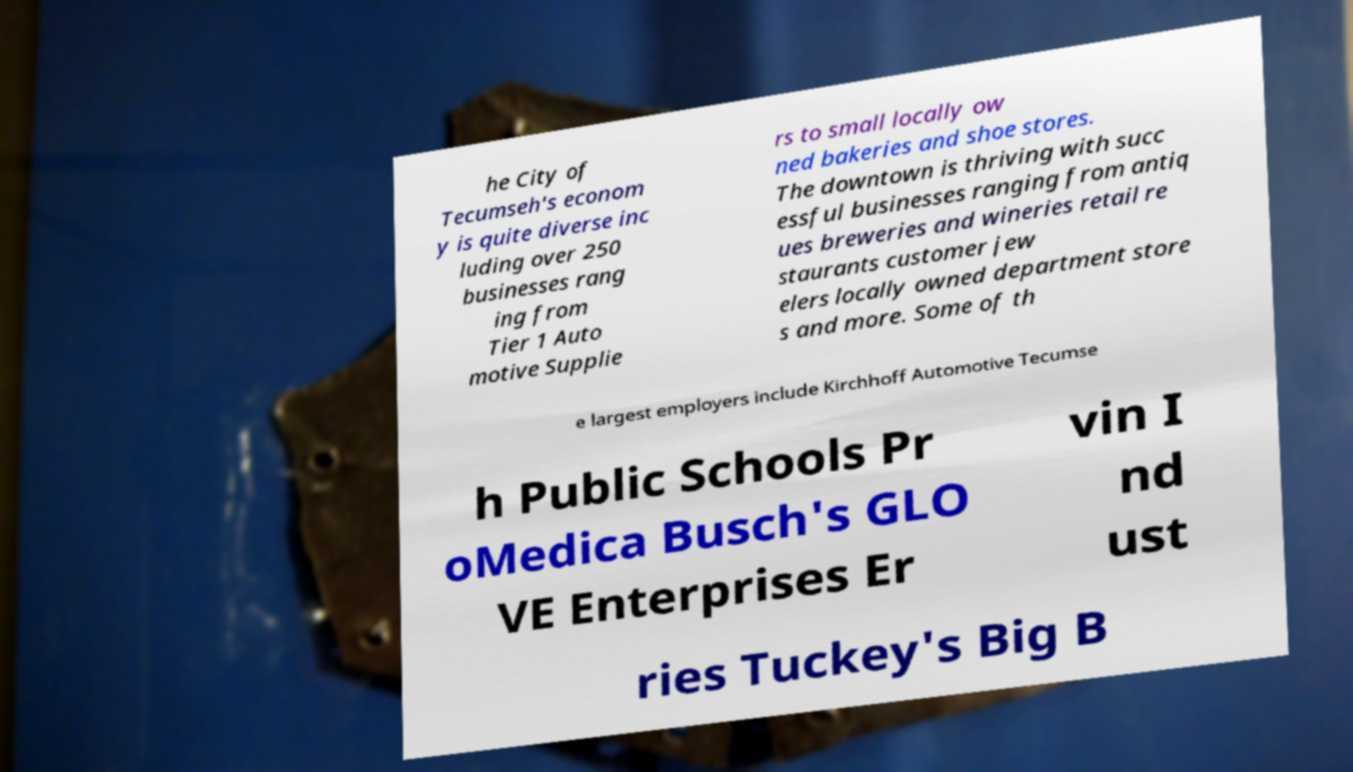Can you read and provide the text displayed in the image?This photo seems to have some interesting text. Can you extract and type it out for me? he City of Tecumseh's econom y is quite diverse inc luding over 250 businesses rang ing from Tier 1 Auto motive Supplie rs to small locally ow ned bakeries and shoe stores. The downtown is thriving with succ essful businesses ranging from antiq ues breweries and wineries retail re staurants customer jew elers locally owned department store s and more. Some of th e largest employers include Kirchhoff Automotive Tecumse h Public Schools Pr oMedica Busch's GLO VE Enterprises Er vin I nd ust ries Tuckey's Big B 